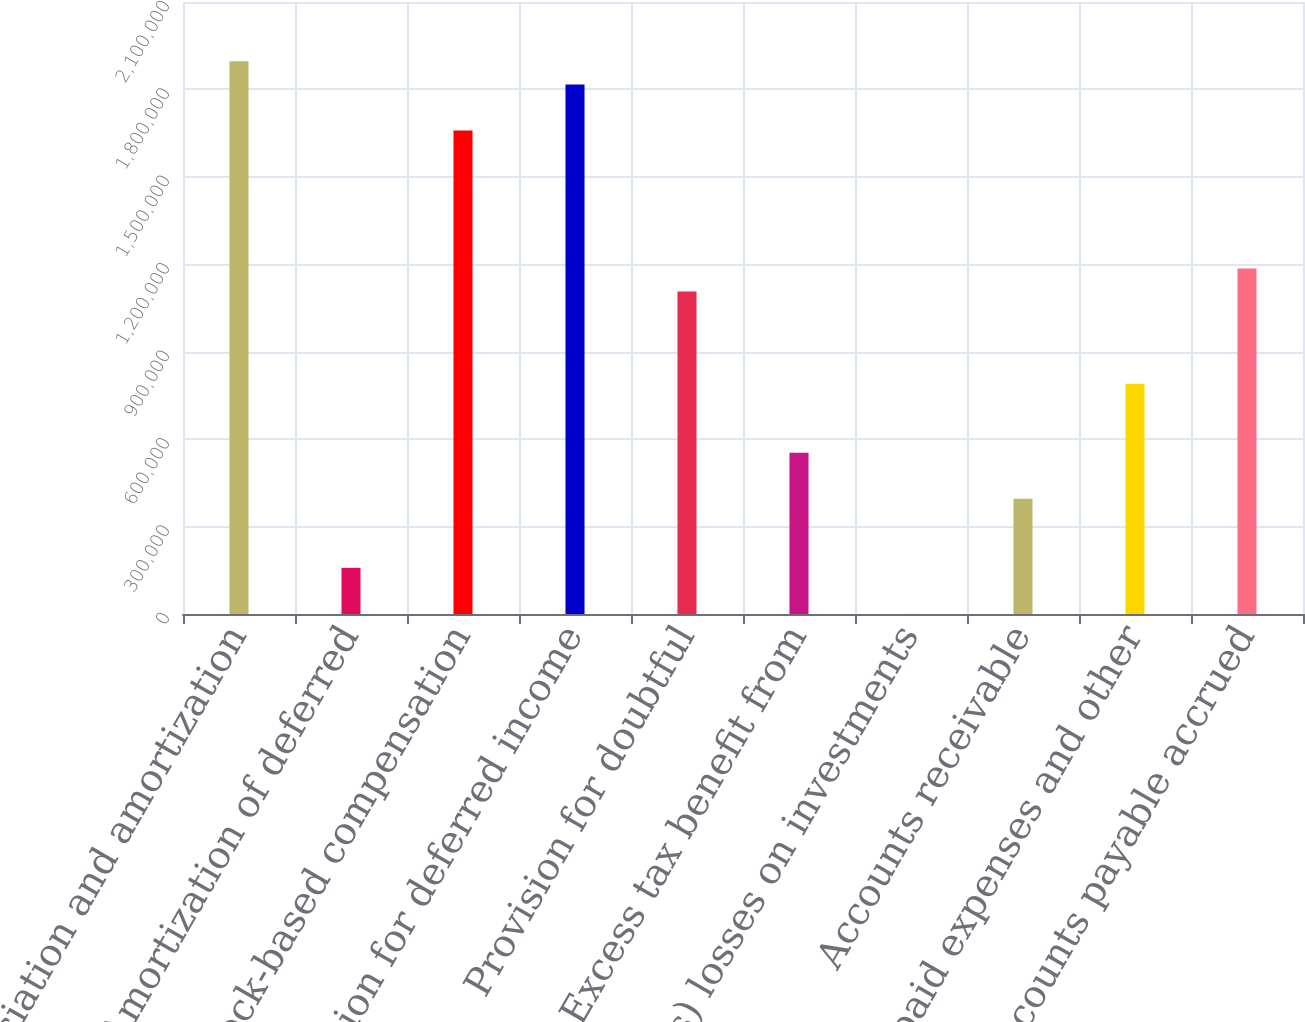<chart> <loc_0><loc_0><loc_500><loc_500><bar_chart><fcel>Depreciation and amortization<fcel>Amortization of deferred<fcel>Stock-based compensation<fcel>Provision for deferred income<fcel>Provision for doubtful<fcel>Excess tax benefit from<fcel>(Gains) losses on investments<fcel>Accounts receivable<fcel>Prepaid expenses and other<fcel>Accounts payable accrued<nl><fcel>1.8963e+06<fcel>158383<fcel>1.65931e+06<fcel>1.8173e+06<fcel>1.10634e+06<fcel>553363<fcel>391<fcel>395371<fcel>790351<fcel>1.18533e+06<nl></chart> 